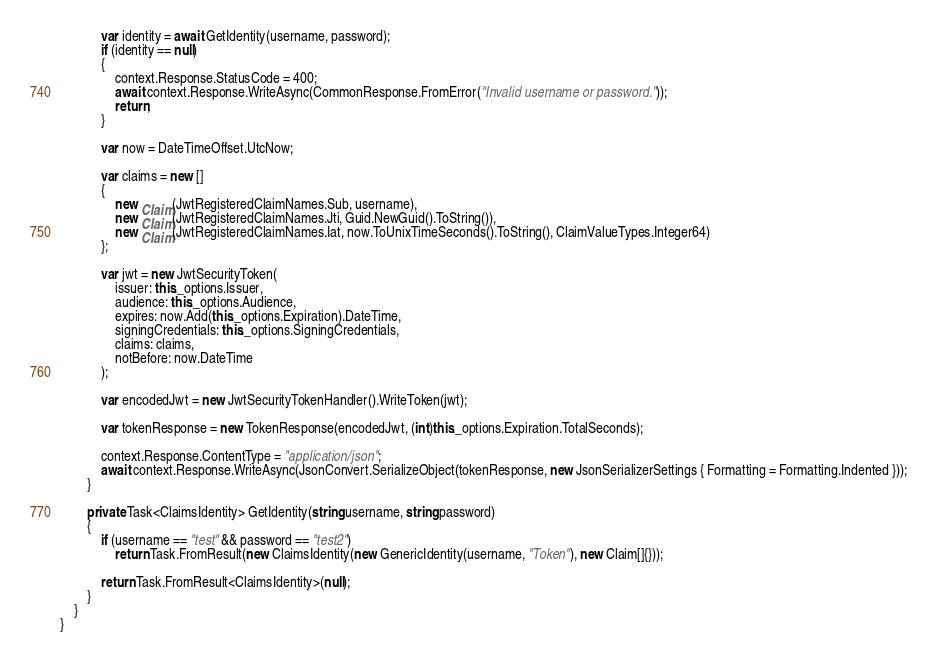<code> <loc_0><loc_0><loc_500><loc_500><_C#_>
            var identity = await GetIdentity(username, password);
            if (identity == null)
            {
                context.Response.StatusCode = 400;
                await context.Response.WriteAsync(CommonResponse.FromError("Invalid username or password."));
                return;
            }

            var now = DateTimeOffset.UtcNow;

            var claims = new []
            {
                new Claim(JwtRegisteredClaimNames.Sub, username),
                new Claim(JwtRegisteredClaimNames.Jti, Guid.NewGuid().ToString()),
                new Claim(JwtRegisteredClaimNames.Iat, now.ToUnixTimeSeconds().ToString(), ClaimValueTypes.Integer64)
            };

            var jwt = new JwtSecurityToken(
                issuer: this._options.Issuer,
                audience: this._options.Audience,
                expires: now.Add(this._options.Expiration).DateTime,
                signingCredentials: this._options.SigningCredentials,
                claims: claims,
                notBefore: now.DateTime
            );

            var encodedJwt = new JwtSecurityTokenHandler().WriteToken(jwt);

            var tokenResponse = new TokenResponse(encodedJwt, (int)this._options.Expiration.TotalSeconds);

            context.Response.ContentType = "application/json";
            await context.Response.WriteAsync(JsonConvert.SerializeObject(tokenResponse, new JsonSerializerSettings { Formatting = Formatting.Indented }));
        }

        private Task<ClaimsIdentity> GetIdentity(string username, string password)
        {
            if (username == "test" && password == "test2")
                return Task.FromResult(new ClaimsIdentity(new GenericIdentity(username, "Token"), new Claim[]{}));

            return Task.FromResult<ClaimsIdentity>(null);
        }
    }
}</code> 